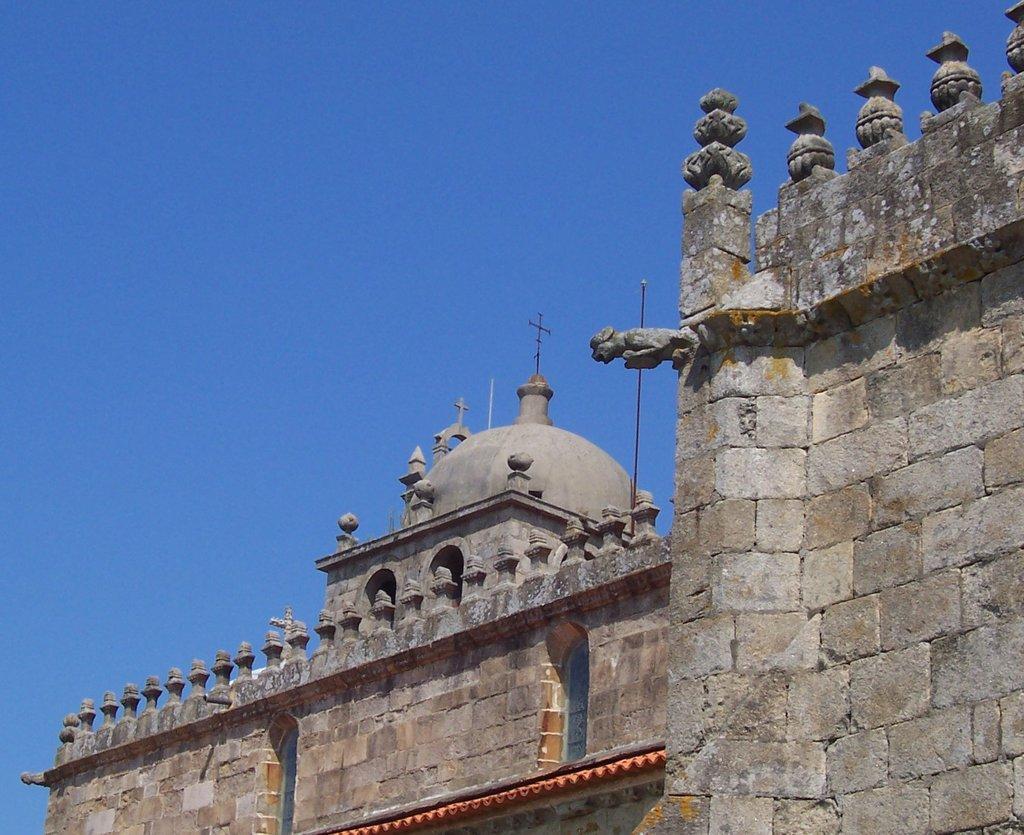Can you describe this image briefly? There is a building with brick wall. On the building there are small pillars. And on the top of the building there are crosses. In the background there is sky. 